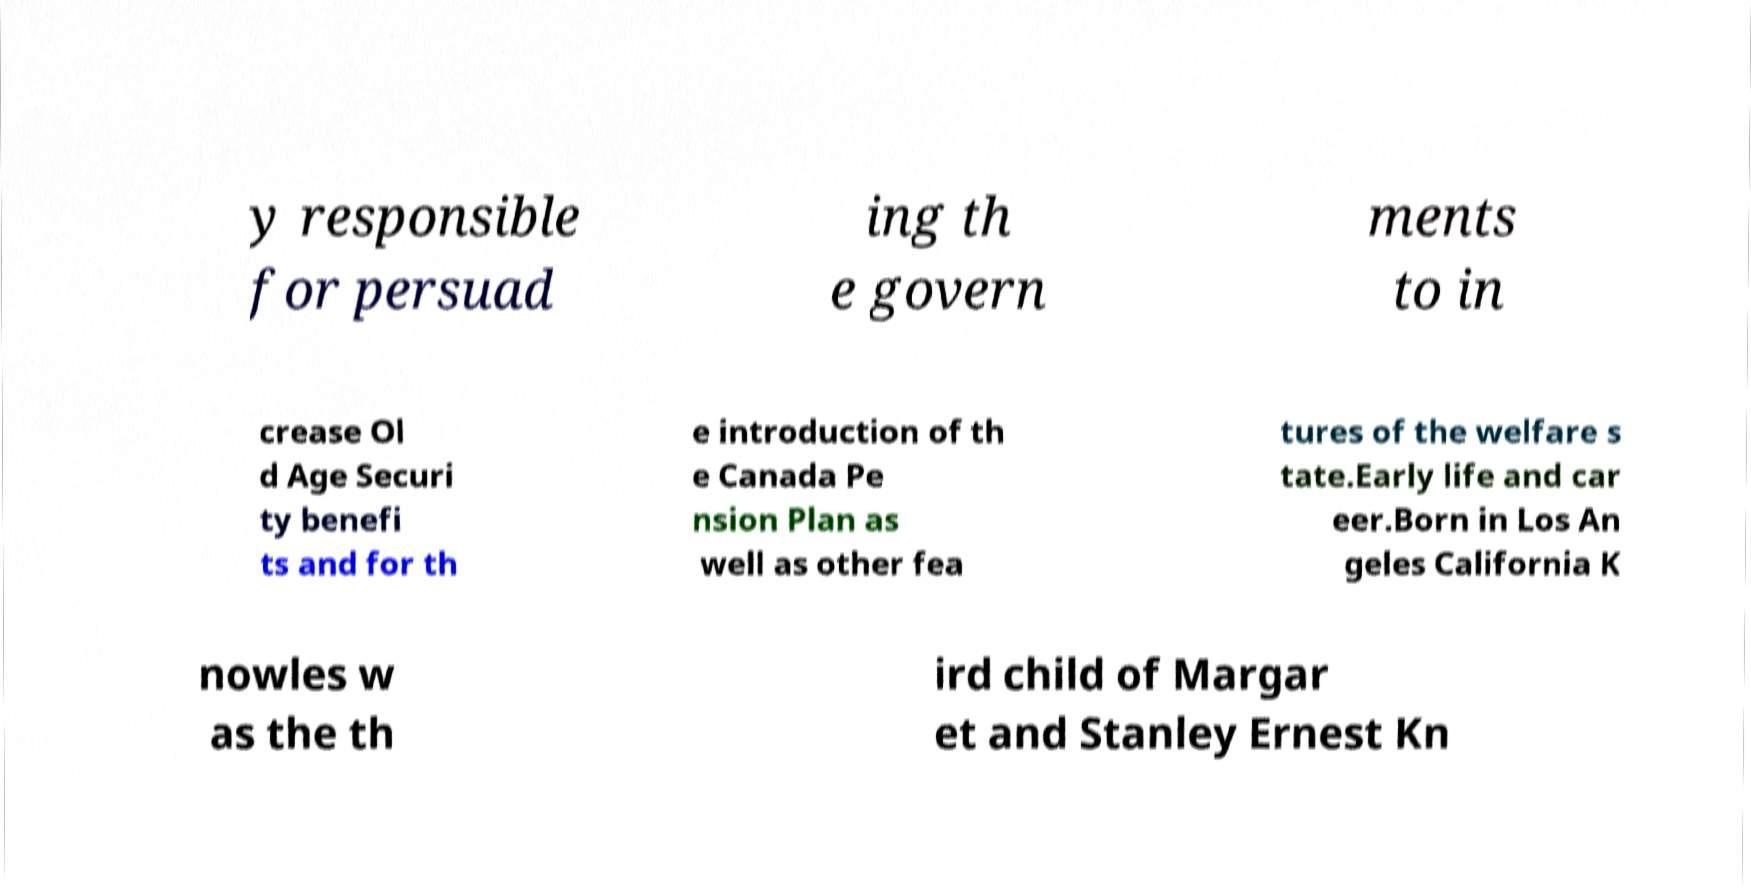Please read and relay the text visible in this image. What does it say? y responsible for persuad ing th e govern ments to in crease Ol d Age Securi ty benefi ts and for th e introduction of th e Canada Pe nsion Plan as well as other fea tures of the welfare s tate.Early life and car eer.Born in Los An geles California K nowles w as the th ird child of Margar et and Stanley Ernest Kn 